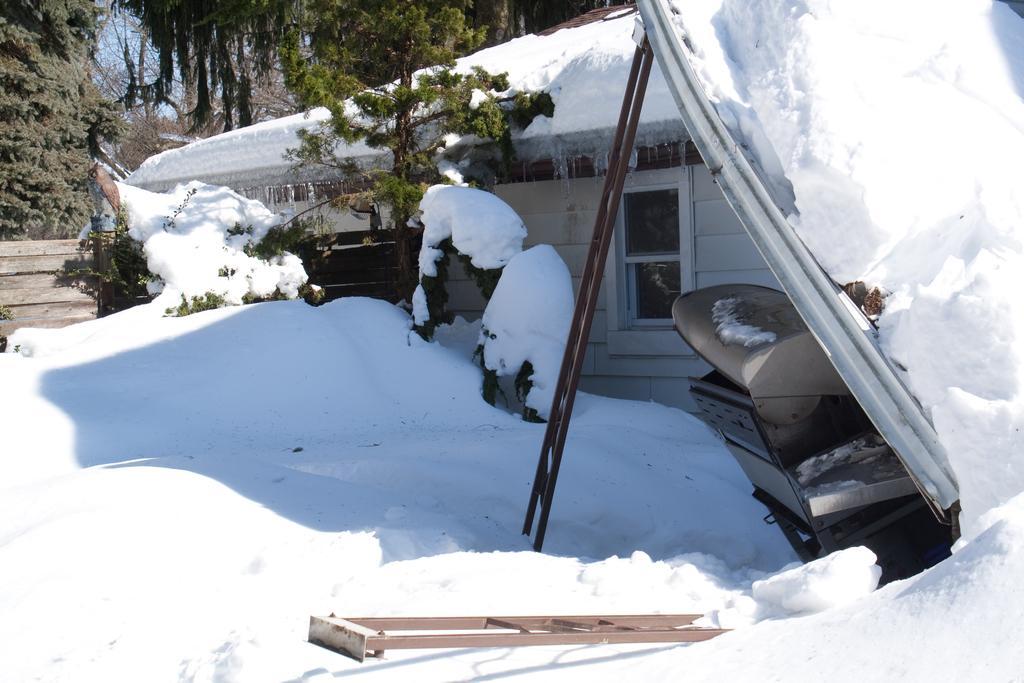Could you give a brief overview of what you see in this image? In this picture we can see a house with window and snow fallen on it and aside to this we have tree, car and some ladder is placed here and the background we can see bushes and sky in between that bushes. 